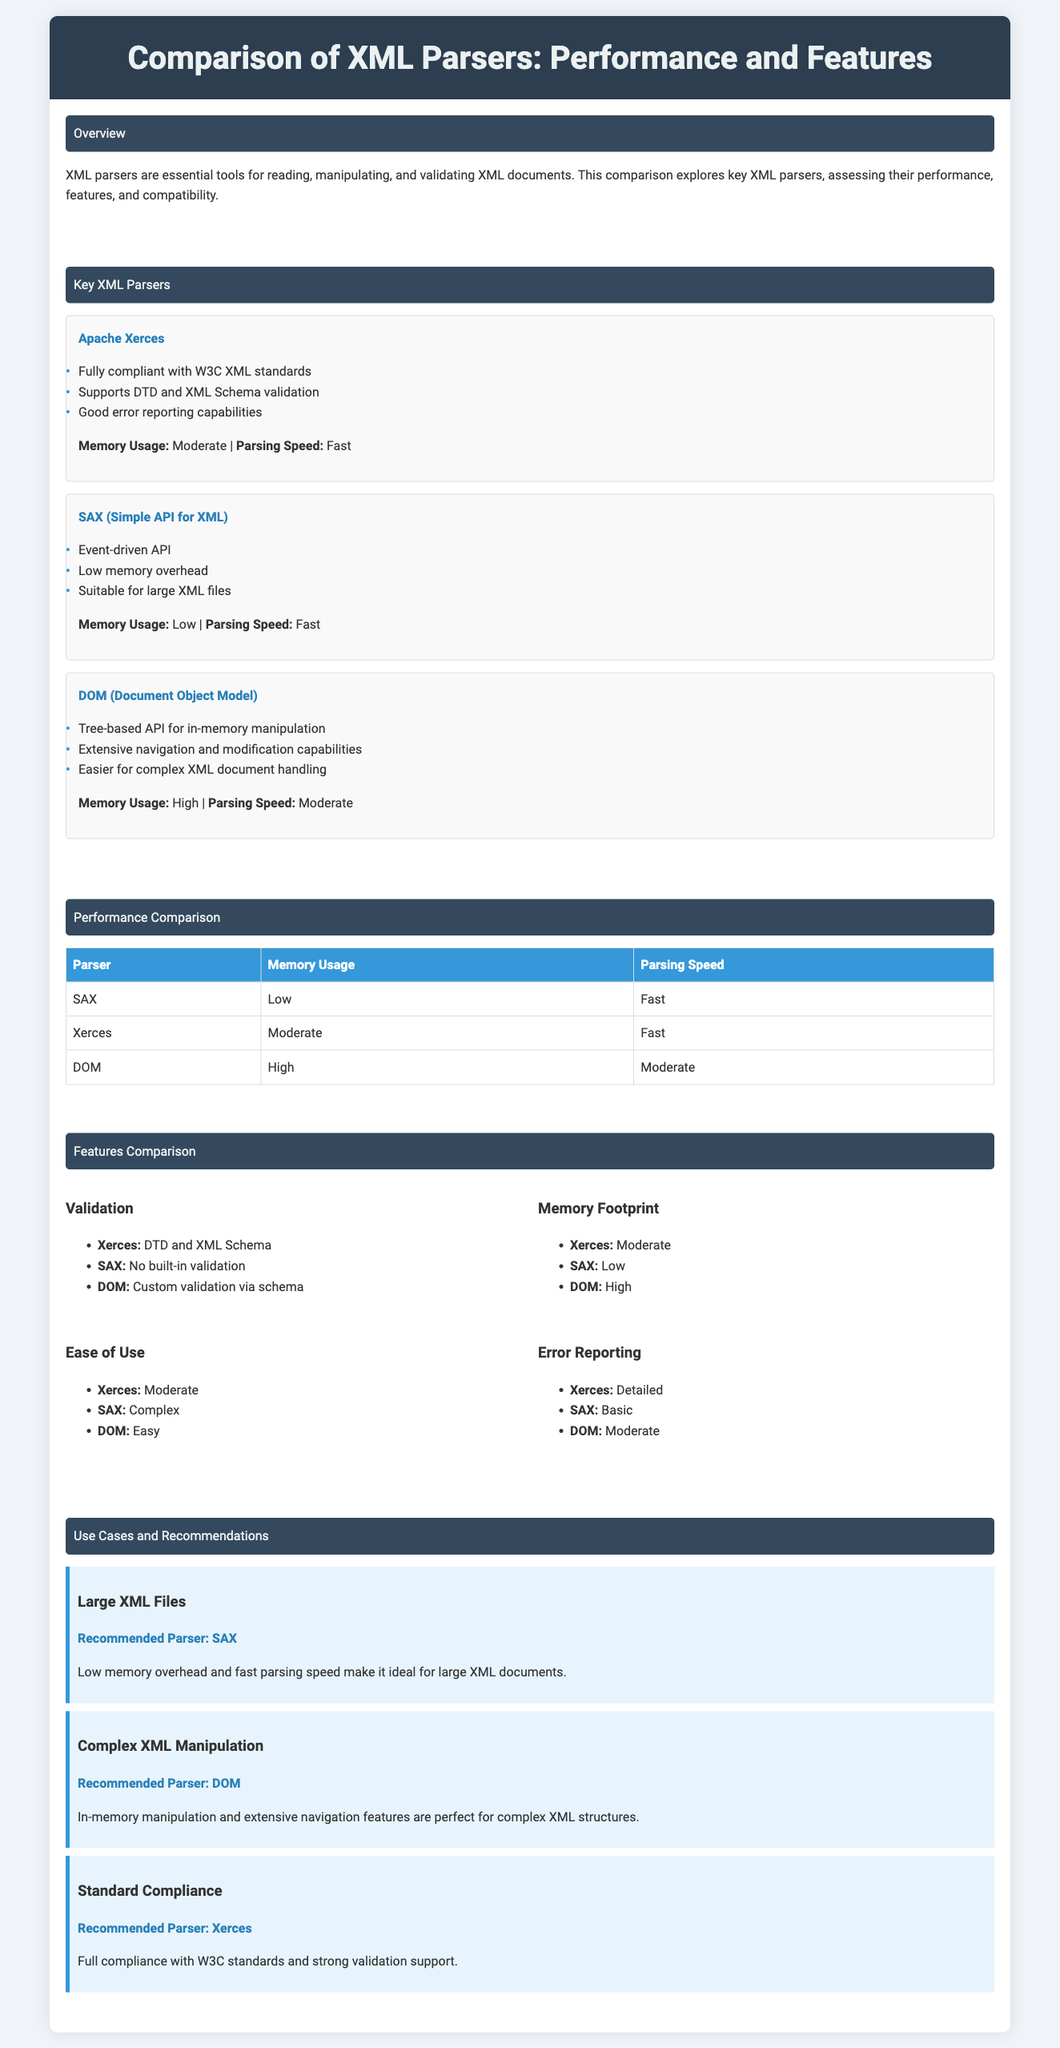What is the title of the infographic? The title of the infographic is presented at the top section of the document, stating the purpose of the content.
Answer: Comparison of XML Parsers: Performance and Features Which parser has the lowest memory usage? This information can be found in the performance comparison table, showing the memory usage of each parser.
Answer: SAX What feature does Xerces support for validation? The document lists the validation features for each parser, indicating what Xerces can handle.
Answer: DTD and XML Schema What is the recommended parser for large XML files? The recommendations section specifies which parser is best suited for handling large XML documents.
Answer: SAX How is the parsing speed categorized for the DOM parser? The performance section provides details about the parsing speed of each parser, including DOME.
Answer: Moderate Which parser offers detailed error reporting? The features comparison section outlines the error reporting capabilities of each parser.
Answer: Xerces What type of API does SAX use? The characteristics of SAX are highlighted in the key parsers section, indicating its API type.
Answer: Event-driven API Which parser is recommended for complex XML manipulation? The use cases section gives insights into which parser is better suited for manipulating complex XML structures.
Answer: DOM 